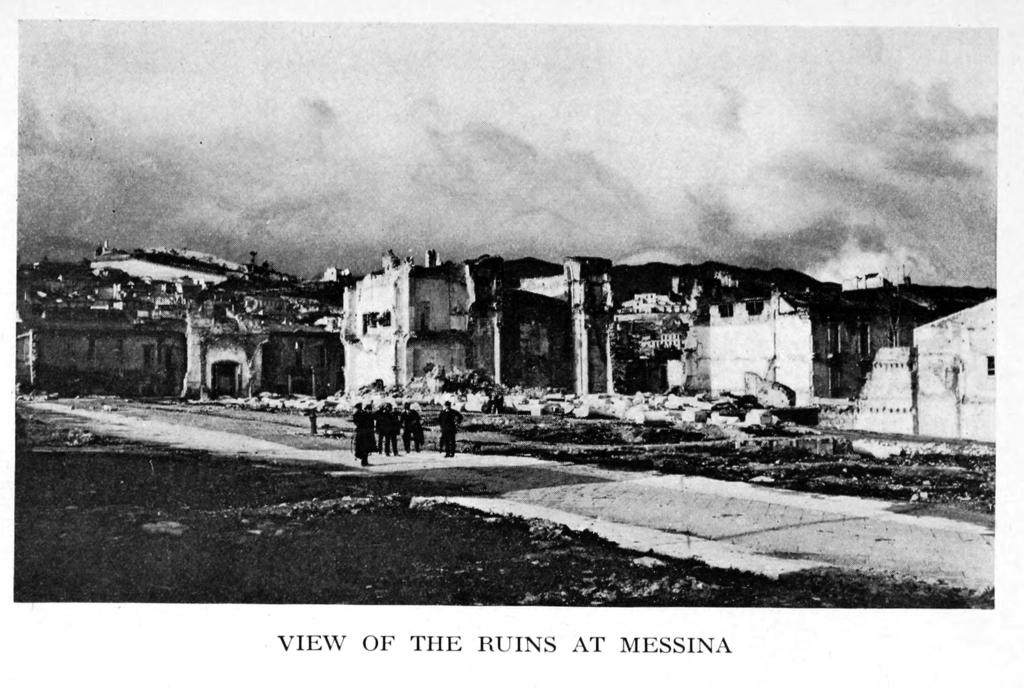What is the main subject in the foreground of the image? There is a crowd in the foreground of the image. Where is the crowd located? The crowd is on the road. What can be seen in the background of the image? There are buildings in the background of the image. What is visible at the top of the image? The sky is visible at the top of the image. Can you tell if the image was taken during the day or night? The image may have been taken during the night, as there is no indication of sunlight or bright daylight. What is the crowd doing with their mouths in the image? There is no information about the crowd's mouths in the image, as the focus is on their location and the surrounding environment. 